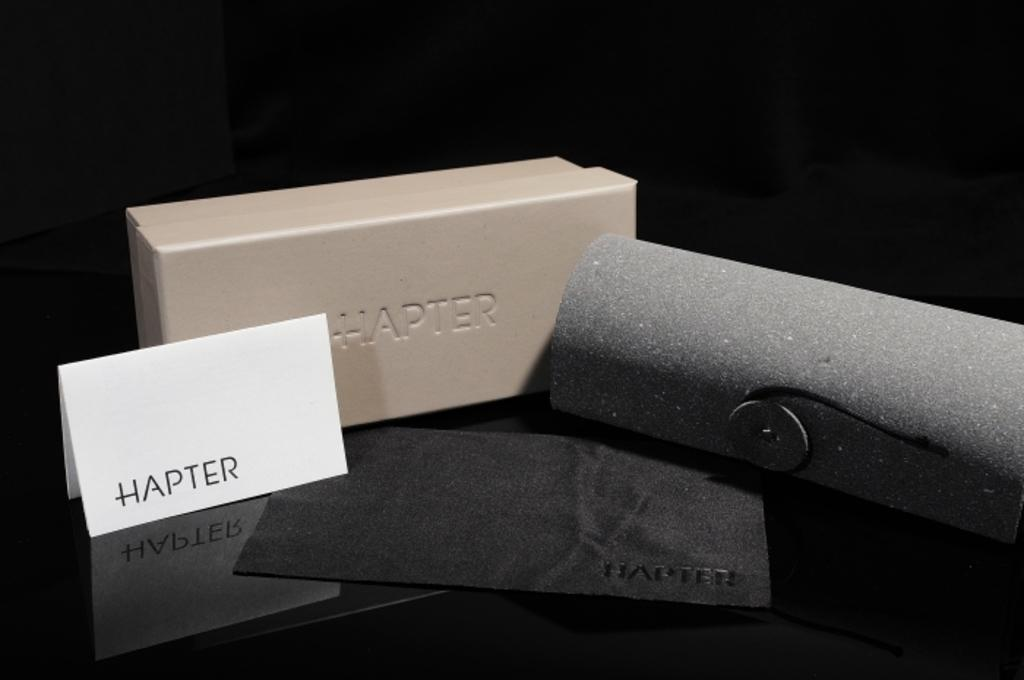<image>
Write a terse but informative summary of the picture. A HAPTER piece of furnishing is attached to a stone wall. 